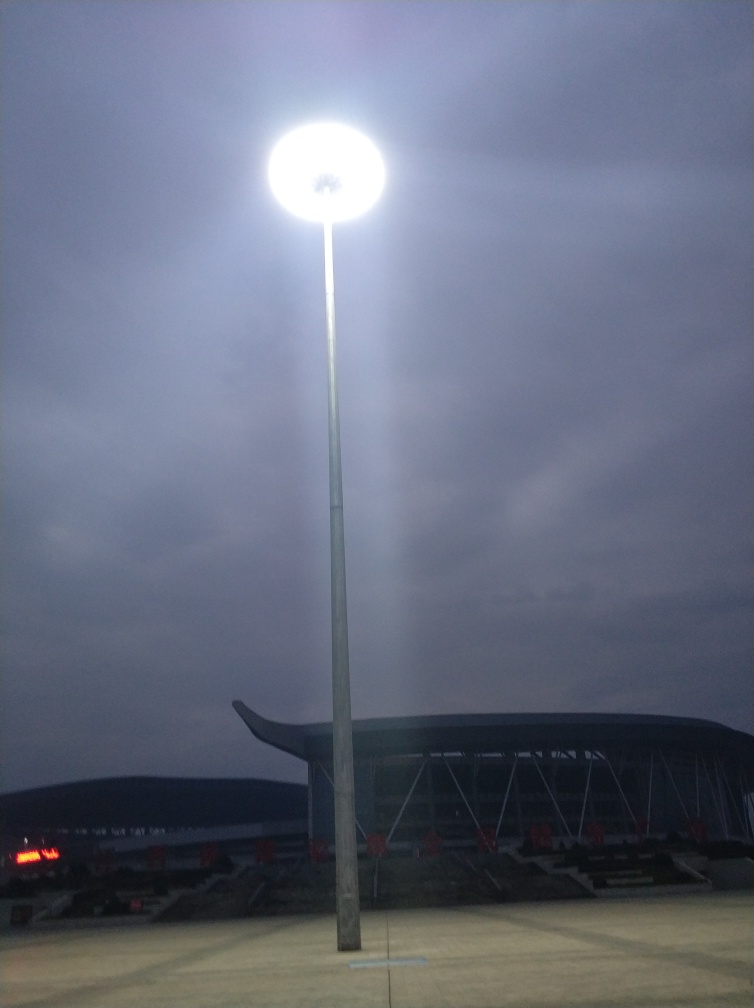Are the specific details of the background buildings clear? The specific details of the background buildings are not clear due to the lighting conditions overwhelming the photo, causing low contrast for finer details. 